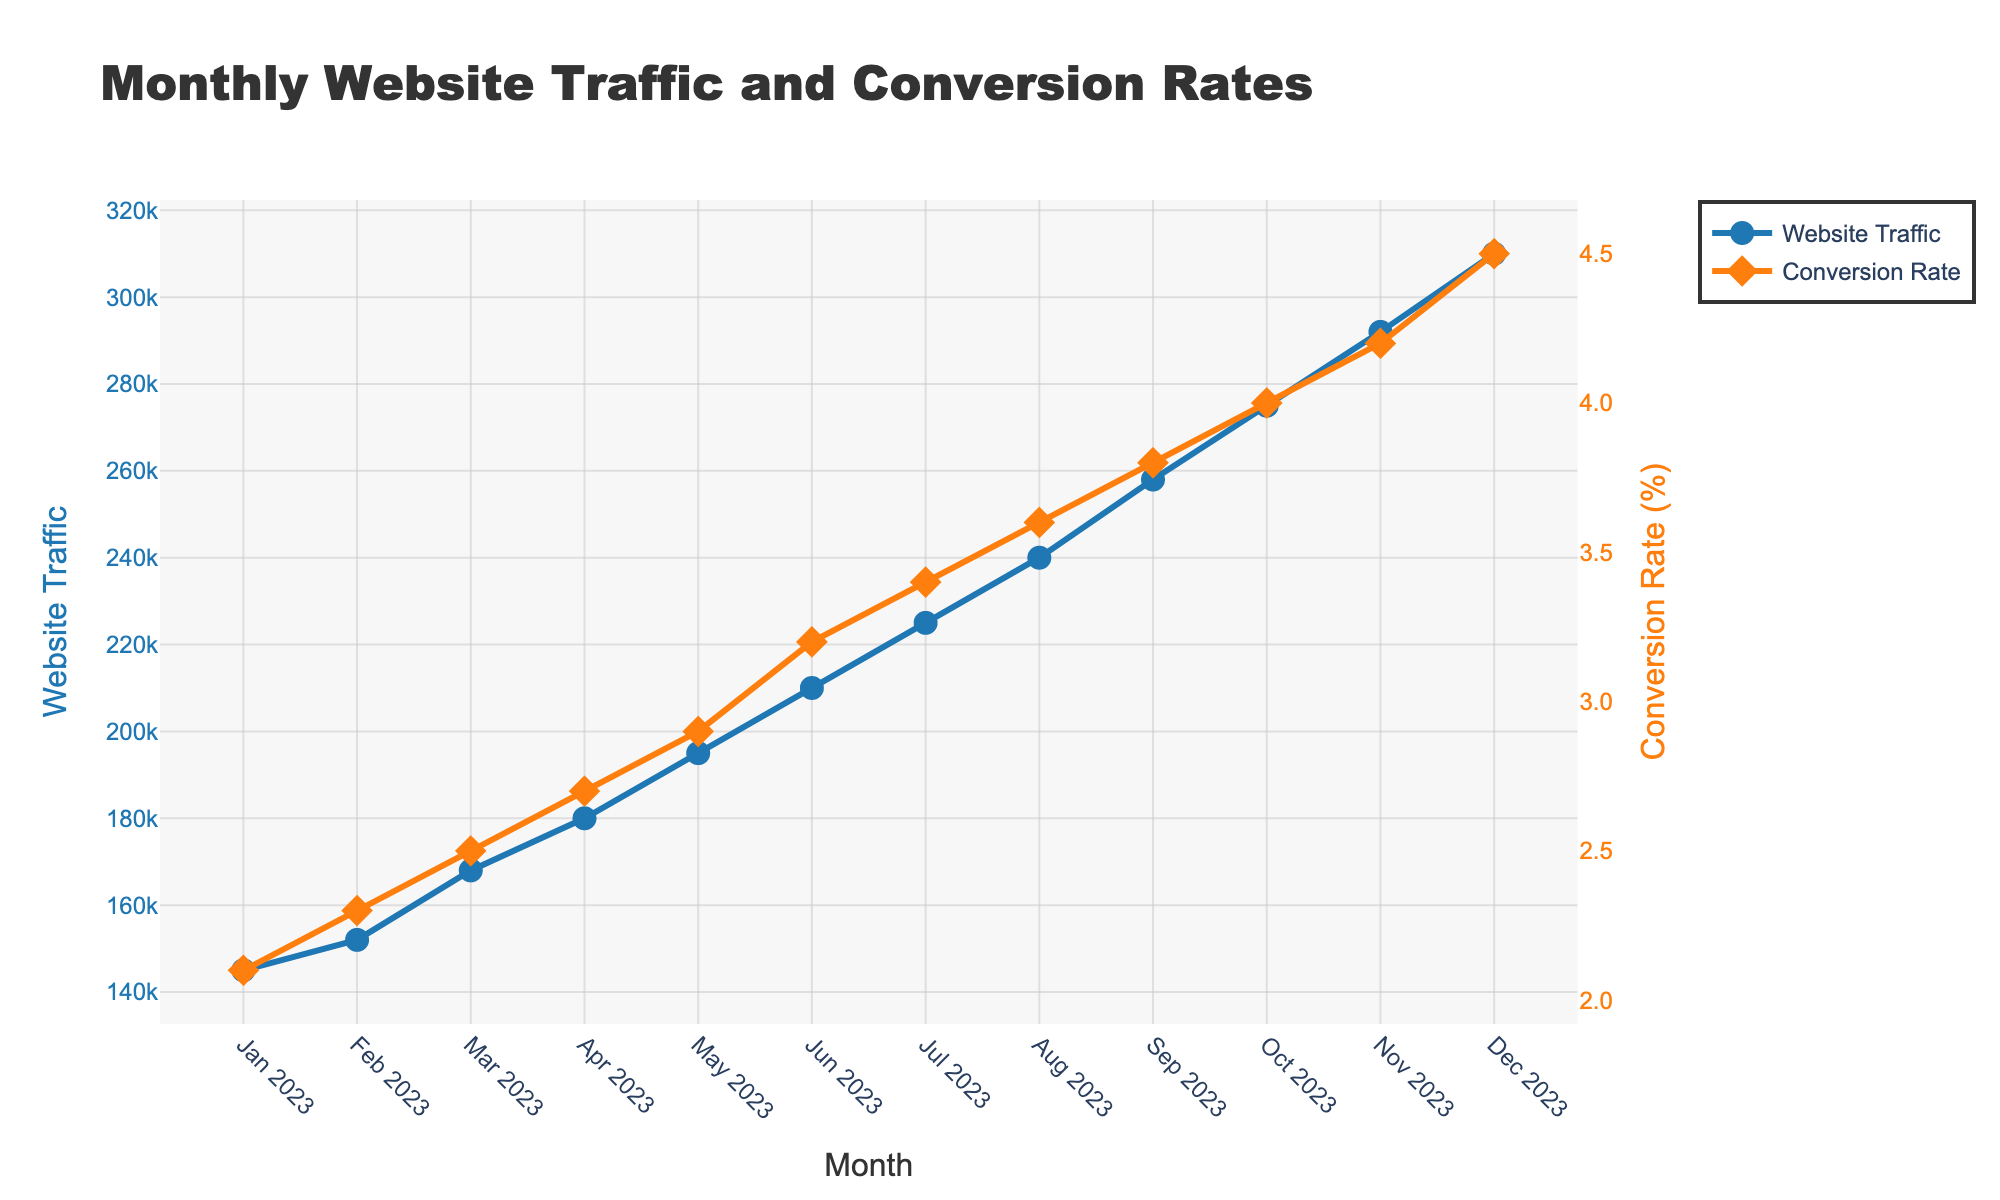What's the total website traffic from Jan 2023 to Dec 2023? Add up the monthly website traffic: 145,000 + 152,000 + 168,000 + 180,000 + 195,000 + 210,000 + 225,000 + 240,000 + 258,000 + 275,000 + 292,000 + 310,000 = 2,650,000
Answer: 2,650,000 Which month had the highest conversion rate? Look at the graph and identify the point with the highest value on the conversion rate line, which occurs in Dec 2023 with 4.5%
Answer: Dec 2023 How much did the conversion rate increase from Jan to Dec 2023? Subtract the conversion rate in Jan 2023 (2.1%) from the conversion rate in Dec 2023 (4.5%): 4.5% - 2.1% = 2.4%
Answer: 2.4% Which month had the largest increase in website traffic compared to the previous month? Calculate the differences month-over-month and find the largest one: 
Feb-Jan (7,000), 
Mar-Feb (16,000), 
Apr-Mar (12,000), 
May-Apr (15,000), 
Jun-May (15,000), 
Jul-Jun (15,000), 
Aug-Jul (15,000), 
Sep-Aug (18,000), 
Oct-Sep (17,000), 
Nov-Oct (17,000), 
Dec-Nov (18,000). The highest increase is from Nov to Dec, Dec-Nov (18,000)
Answer: Dec 2023 How did the overall trend of website traffic change from Jan 2023 to Dec 2023? Examine the line for website traffic: It started at 145,000 in Jan and increased steadily to 310,000 in Dec, indicating a consistent upward trend
Answer: Upward trend Compare the conversion rates between May and Nov 2023. Look at the conversion rates in May (2.9%) and Nov (4.2%): Nov's conversion rate (4.2%) is higher than May's (2.9%)
Answer: Nov's rate is higher Was there any month where both website traffic and conversion rates did not increase from the previous month? Examine both lines month by month: All months show an increase in both website traffic and conversion rates, with no exceptions
Answer: No How much did the website traffic increase on average each month? Find the total increase in website traffic: 310,000 - 145,000 = 165,000. Divide by the number of months: 165,000 / 11 ≈ 15,000 per month
Answer: ≈ 15,000 What was the average conversion rate over the year 2023? Sum the conversion rates and divide by the number of months: (2.1 + 2.3 + 2.5 + 2.7 + 2.9 + 3.2 + 3.4 + 3.6 + 3.8 + 4.0 + 4.2 + 4.5) / 12 ≈ 3.375
Answer: ≈ 3.375 Between which two consecutive months did website traffic grow the least? Calculate the month-to-month differences: 
Feb-Jan (7,000), 
Mar-Feb (16,000), 
Apr-Mar (12,000), 
May-Apr (15,000), 
Jun-May (15,000), 
Jul-Jun (15,000), 
Aug-Jul (15,000), 
Sep-Aug (18,000), 
Oct-Sep (17,000), 
Nov-Oct (17,000), 
Dec-Nov (18,000). The smallest increase is from Jan to Feb, Feb-Jan (7,000)
Answer: Jan to Feb 